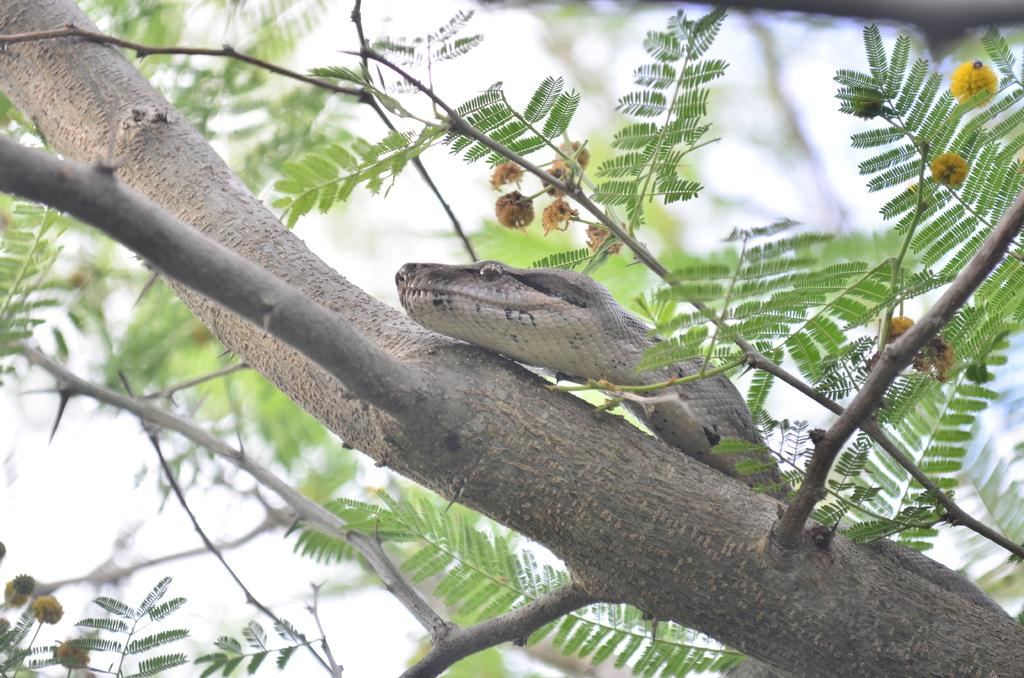What animal is present in the image? There is a snake in the image. Where is the snake located? The snake is on a tree. What part of the natural environment is visible in the image? The sky is visible in the image. What level of difficulty is the snake facing in the image? There is no indication of difficulty or challenge for the snake in the image; it is simply located on a tree. 